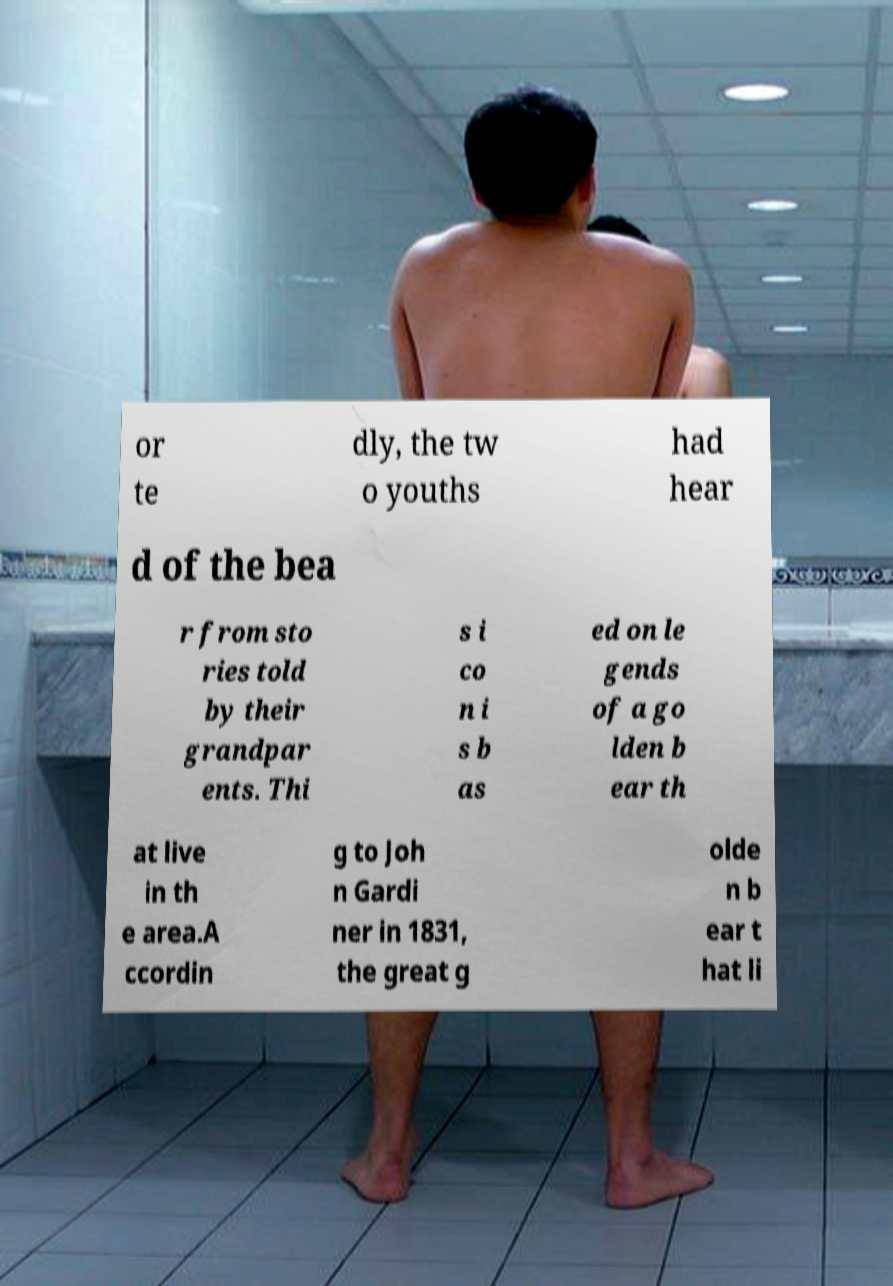For documentation purposes, I need the text within this image transcribed. Could you provide that? or te dly, the tw o youths had hear d of the bea r from sto ries told by their grandpar ents. Thi s i co n i s b as ed on le gends of a go lden b ear th at live in th e area.A ccordin g to Joh n Gardi ner in 1831, the great g olde n b ear t hat li 